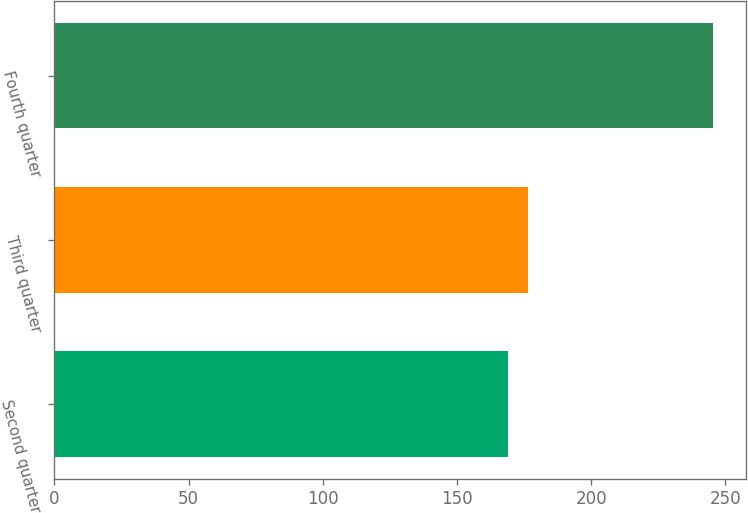Convert chart. <chart><loc_0><loc_0><loc_500><loc_500><bar_chart><fcel>Second quarter<fcel>Third quarter<fcel>Fourth quarter<nl><fcel>168.9<fcel>176.57<fcel>245.57<nl></chart> 